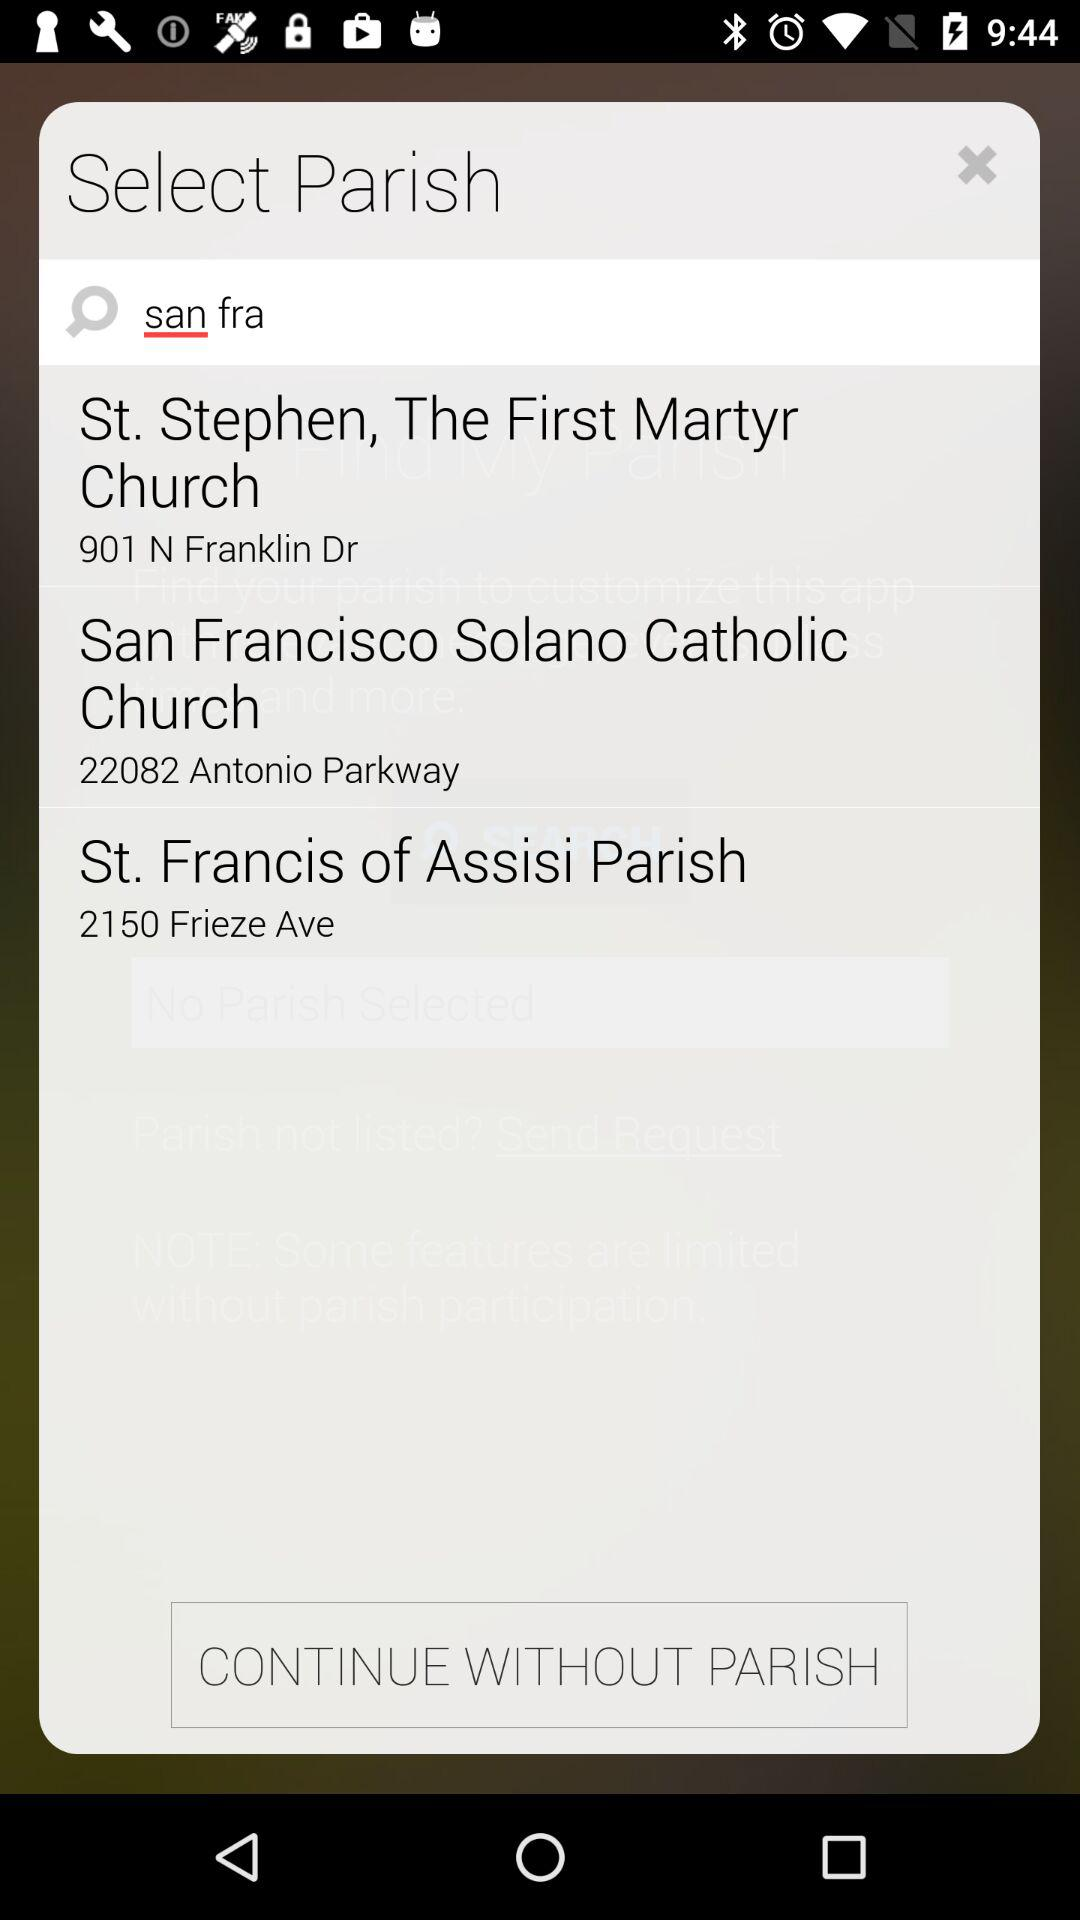What is the address of St. Francis of Assisi Parish? The address is 2150 Frieze Ave. 